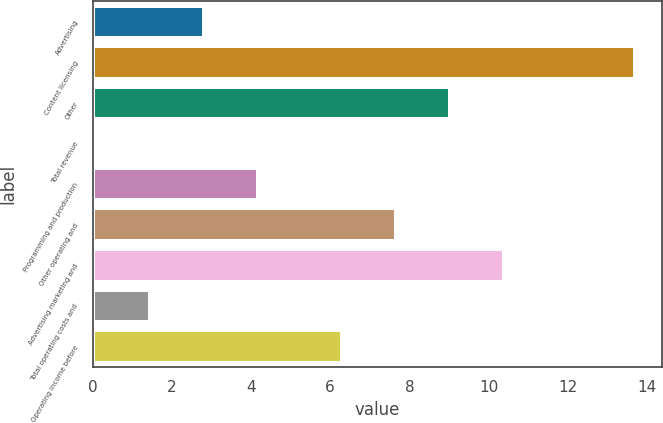Convert chart. <chart><loc_0><loc_0><loc_500><loc_500><bar_chart><fcel>Advertising<fcel>Content licensing<fcel>Other<fcel>Total revenue<fcel>Programming and production<fcel>Other operating and<fcel>Advertising marketing and<fcel>Total operating costs and<fcel>Operating income before<nl><fcel>2.82<fcel>13.7<fcel>9.02<fcel>0.1<fcel>4.18<fcel>7.66<fcel>10.38<fcel>1.46<fcel>6.3<nl></chart> 